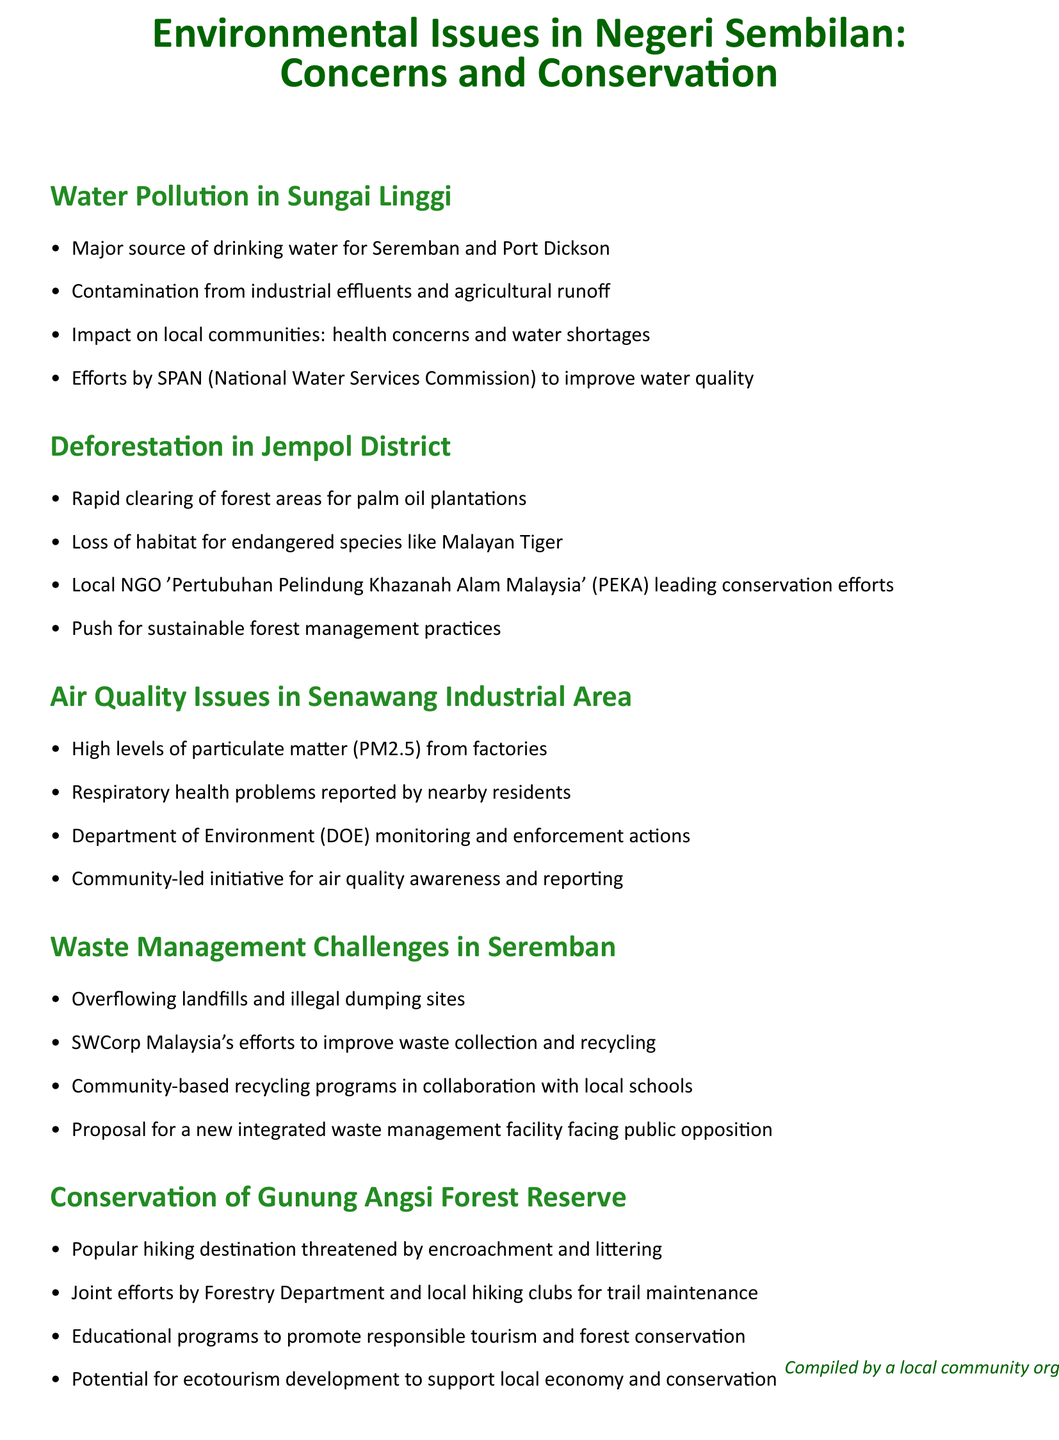What is the major source of drinking water for Seremban? The document states that Sungai Linggi is the major source of drinking water for Seremban and Port Dickson.
Answer: Sungai Linggi What contaminates the drinking water in Sungai Linggi? The content mentions contamination from industrial effluents and agricultural runoff.
Answer: Industrial effluents and agricultural runoff Who is leading conservation efforts in Jempol District? The document identifies the local NGO 'Pertubuhan Pelindung Khazanah Alam Malaysia' (PEKA) as leading conservation efforts.
Answer: Pertubuhan Pelindung Khazanah Alam Malaysia (PEKA) What health problems are reported in the Senawang Industrial Area? The document indicates that respiratory health problems have been reported by nearby residents.
Answer: Respiratory health problems What is one challenge mentioned regarding waste management in Seremban? The document highlights overflowing landfills and illegal dumping sites as challenges in waste management.
Answer: Overflowing landfills What is the potential development that could support both the local economy and conservation in Gunung Angsi? The document mentions potential for ecotourism development to support local economy and conservation.
Answer: Ecotourism development Which department is responsible for monitoring air quality issues in Senawang? The document specifies that the Department of Environment (DOE) is responsible for monitoring and enforcement actions.
Answer: Department of Environment (DOE) What type of programs are initiated in collaboration with local schools in Seremban? The document describes community-based recycling programs in collaboration with local schools.
Answer: Community-based recycling programs 